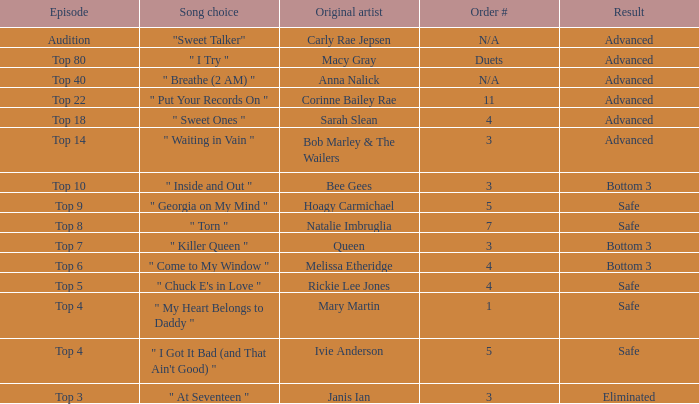What's the order number of the song originally performed by Rickie Lee Jones? 4.0. 